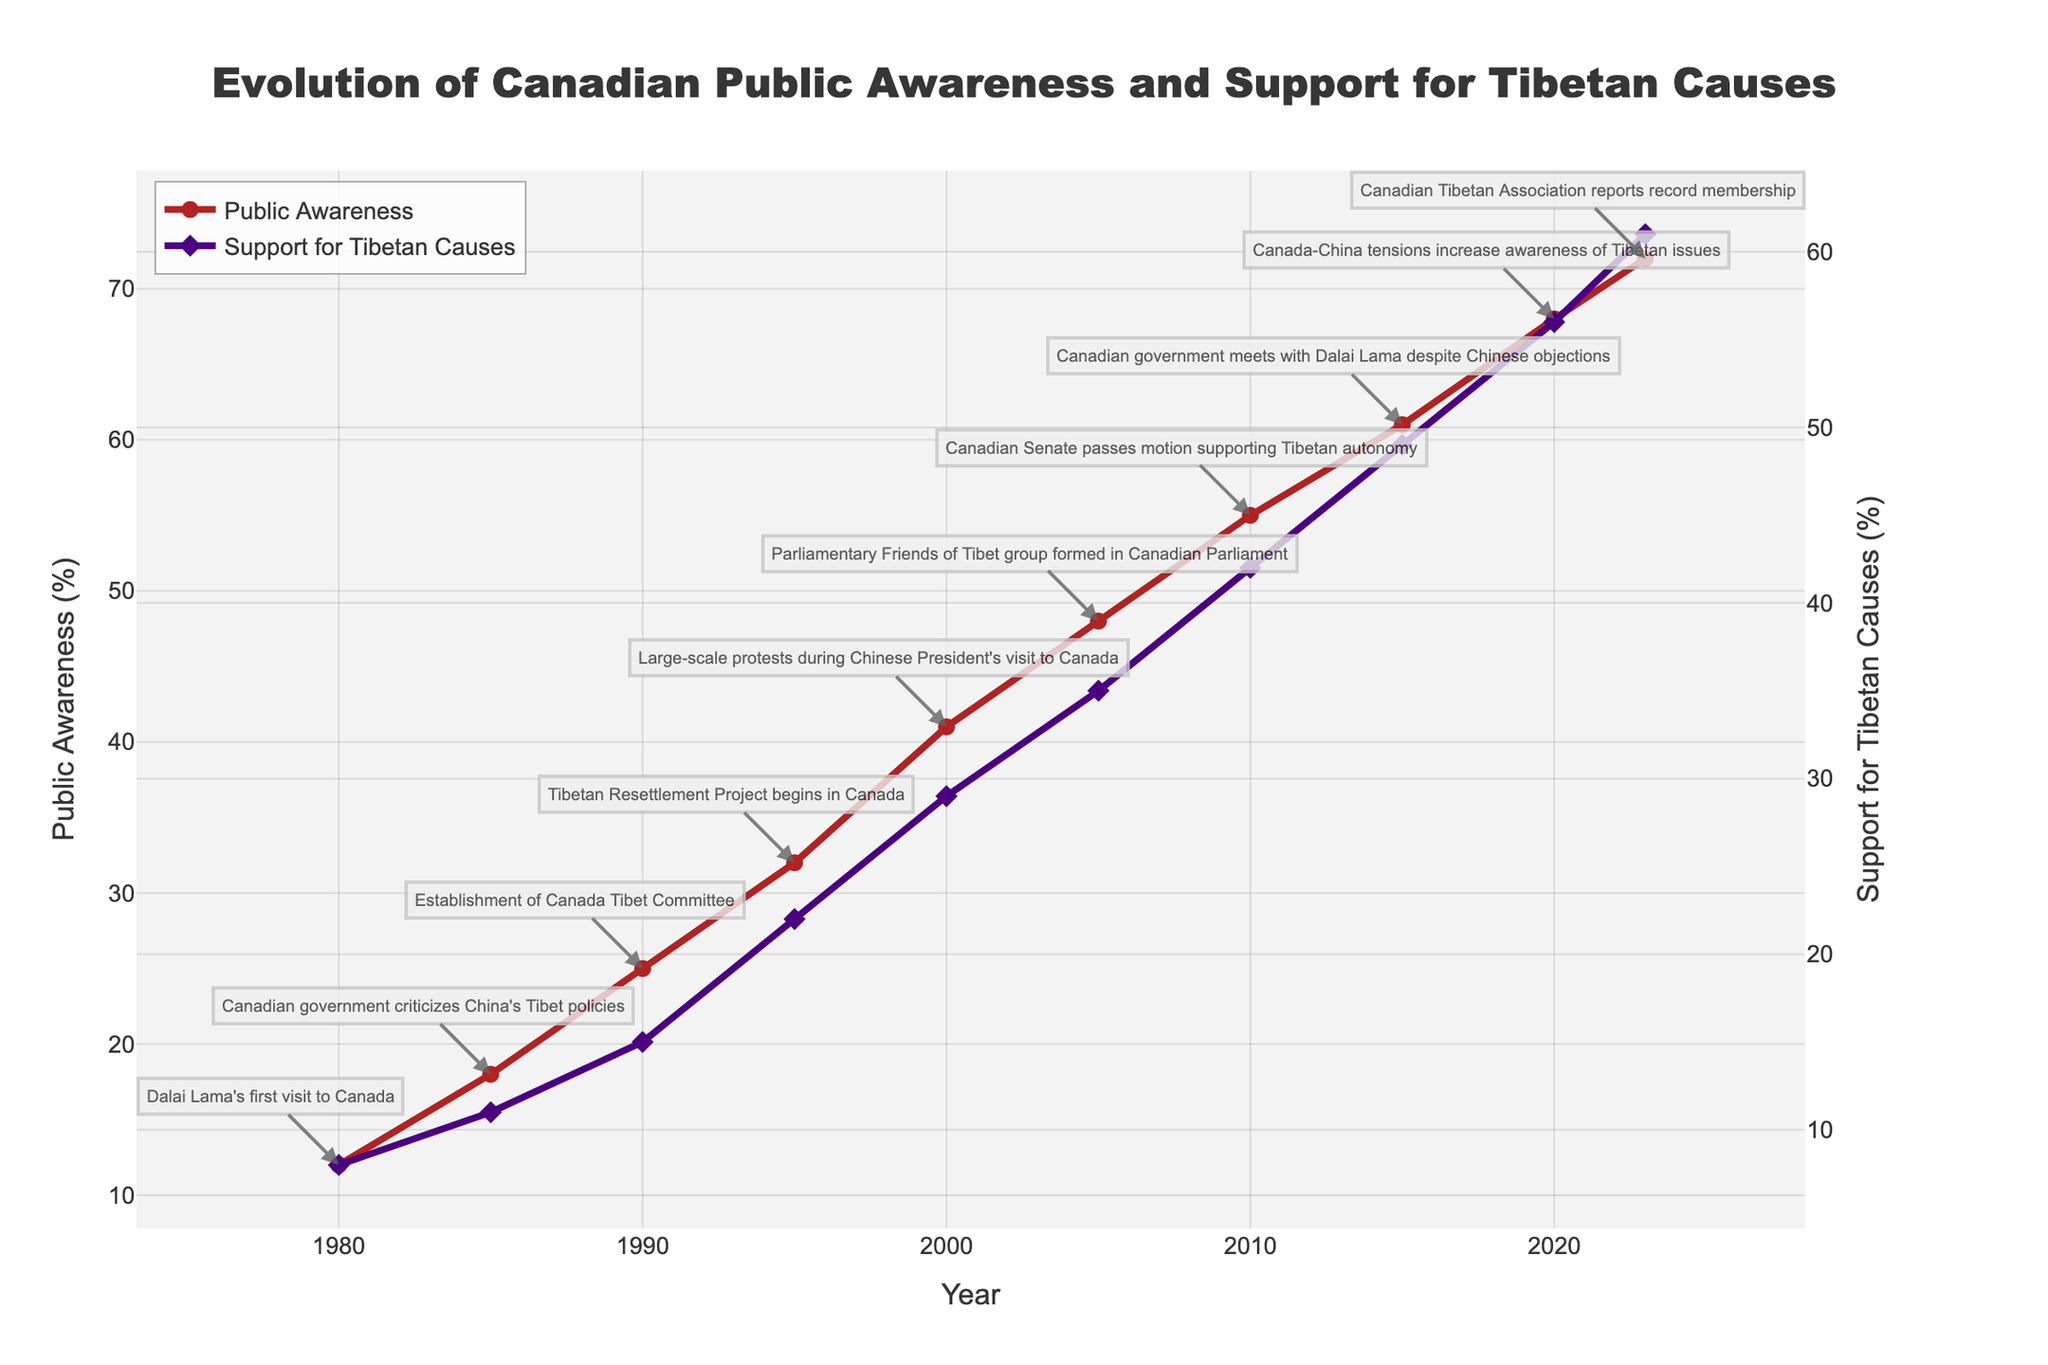What year did Public Awareness first exceed 50%? The figure shows that Public Awareness crossed the 50% threshold between 2005 and 2010, and reached 55% in 2010.
Answer: 2010 Which year had the highest Support for Tibetan Causes? The figure shows that the Support for Tibetan Causes peaked in 2023 at 61%.
Answer: 2023 By how much did Public Awareness increase from 1980 to 2023? Public Awareness was 12% in 1980 and 72% in 2023, so the increase is 72 - 12 = 60%.
Answer: 60% What major event corresponded with the largest one-time jump in Public Awareness? According to the annotations, the biggest jump in Public Awareness occurred between 2000 and 2005, corresponding with the formation of the Parliamentary Friends of Tibet group.
Answer: Formation of Parliamentary Friends of Tibet What was the value of Support for Tibetan Causes in 1995? The figure shows a diamond marker at 1995 on the Support for Tibetan Causes line, which corresponds to 22%.
Answer: 22% When did the gap between Public Awareness and Support for Tibetan Causes first reach 20%? The gap first reached 20% in 1995, with Public Awareness at 32% and Support for Tibetan Causes at 22% (32 - 22 = 10%). By 2000, the gap is more than 20%.
Answer: 1995 Which milestone event corresponds with the first data point where Public Awareness reaches above 40%? The first instance of Public Awareness going above 40% is in 2000 and coincides with the large-scale protests during the Chinese President's visit to Canada.
Answer: Large-scale protests during Chinese President's visit What was the approximate rate of increase in Public Awareness from 2010 to 2020? Public Awareness increased from 55% in 2010 to 68% in 2020. The rate of increase is (68 - 55) / (2020 - 2010) = 13 / 10 = 1.3% per year.
Answer: 1.3% per year Did any major event correlate with both a substantial rise in Public Awareness and Support for Tibetan Causes simultaneously? The figure indicates that in 1985, there was an increase in both Public Awareness (from 12% to 18%) and Support for Tibetan Causes (from 8% to 11%) following Canada's criticism of China's Tibet policies.
Answer: Canada's criticism of China's Tibet policies 